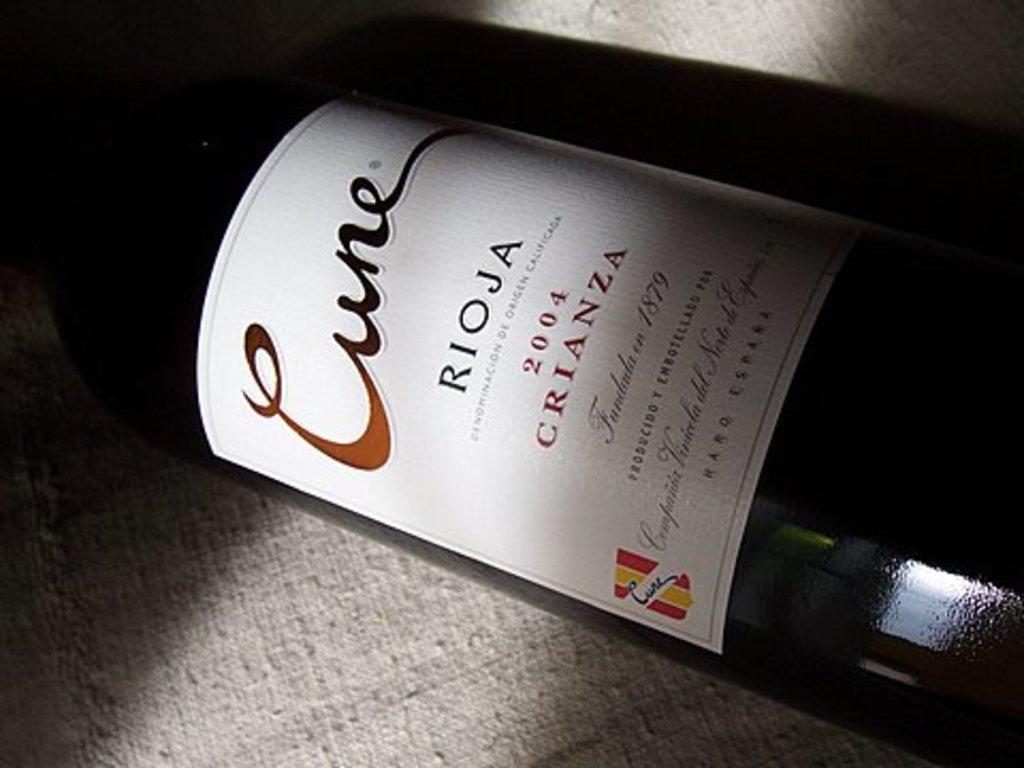What's the name of this wine brand?
Provide a short and direct response. Cune. What year was this wine made?
Offer a very short reply. 2004. 